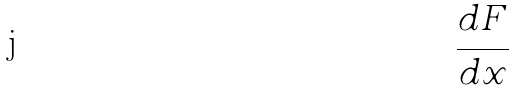Convert formula to latex. <formula><loc_0><loc_0><loc_500><loc_500>\frac { d F } { d x }</formula> 